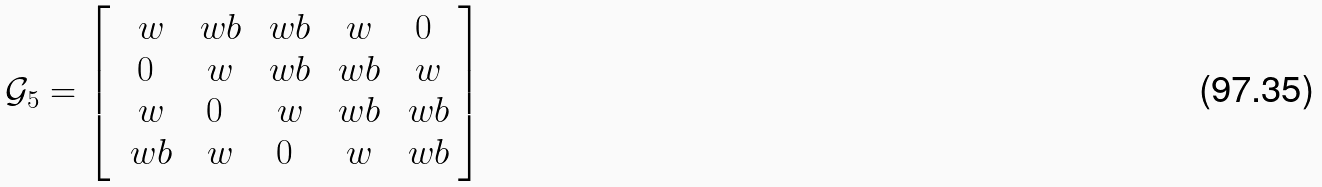Convert formula to latex. <formula><loc_0><loc_0><loc_500><loc_500>\mathcal { G } _ { 5 } = \left [ \begin{array} { c c c c c } \ w & \ w b & \ w b & \ w & 0 \\ 0 & \ w & \ w b & \ w b & \ w \\ \ w & 0 & \ w & \ w b & \ w b \\ \ w b & \ w & 0 & \ w & \ w b \end{array} \right ]</formula> 